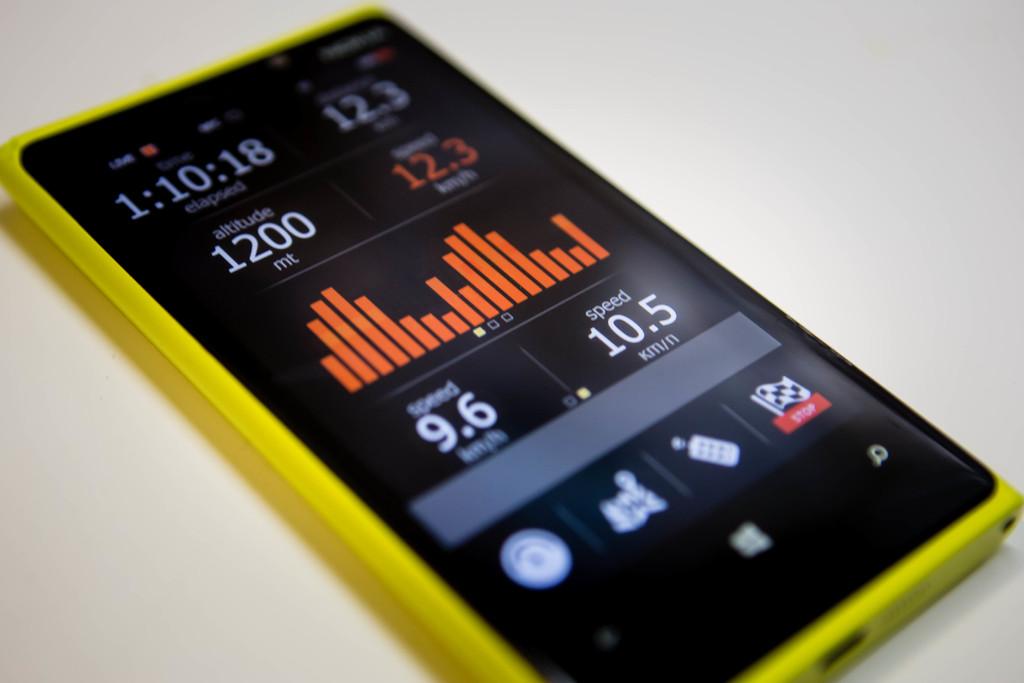What is the speed?
Provide a succinct answer. 10.5. 